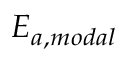Convert formula to latex. <formula><loc_0><loc_0><loc_500><loc_500>E _ { a , m o d a l }</formula> 